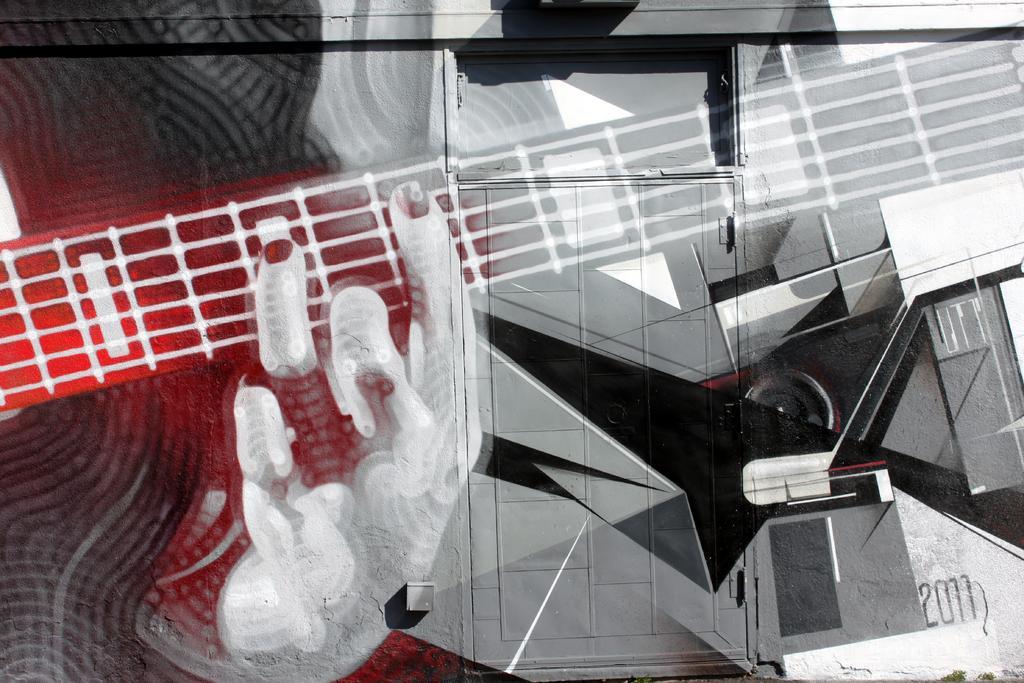Can you describe this image briefly? In this image we can see a person is holding a musical instrument. This is speaker. 